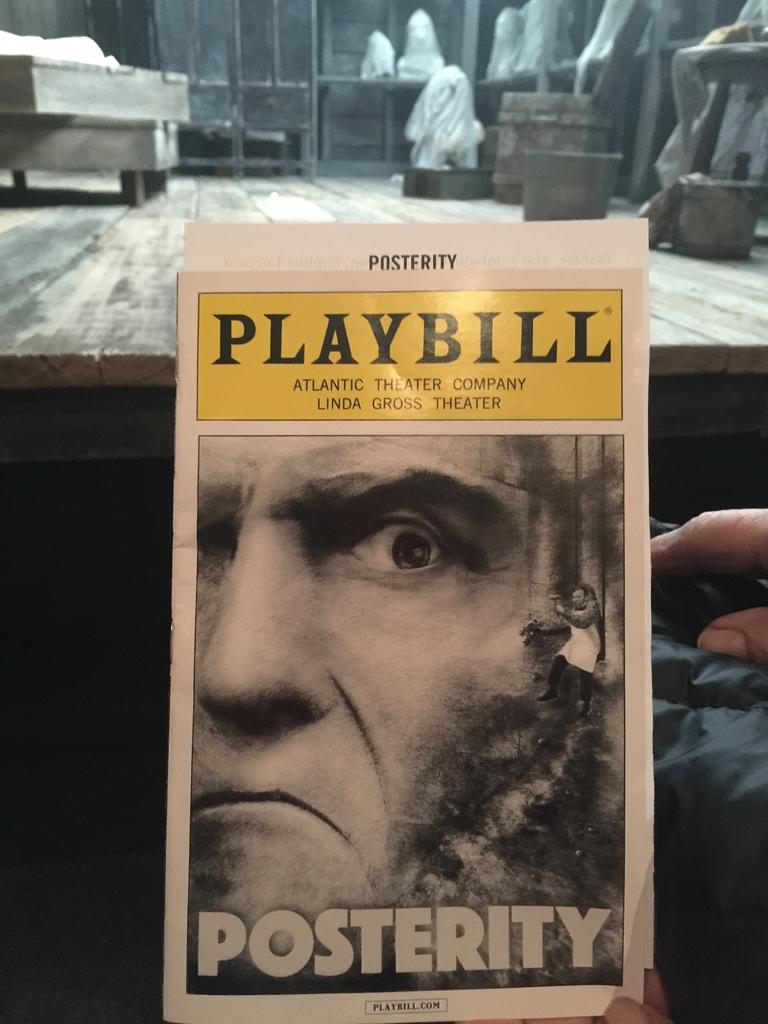Who is depicted on the poster in the image? There is a poster of a man in the image. Where is the poster located in relation to other objects in the image? The poster is in front of a table. What items can be seen on the table in the image? There are buckets on the table. What type of flame can be seen on the poster in the image? There is no flame present on the poster in the image; it features a man. What mathematical operation is being performed on the poster in the image? There is no mathematical operation depicted on the poster in the image; it features a man. 